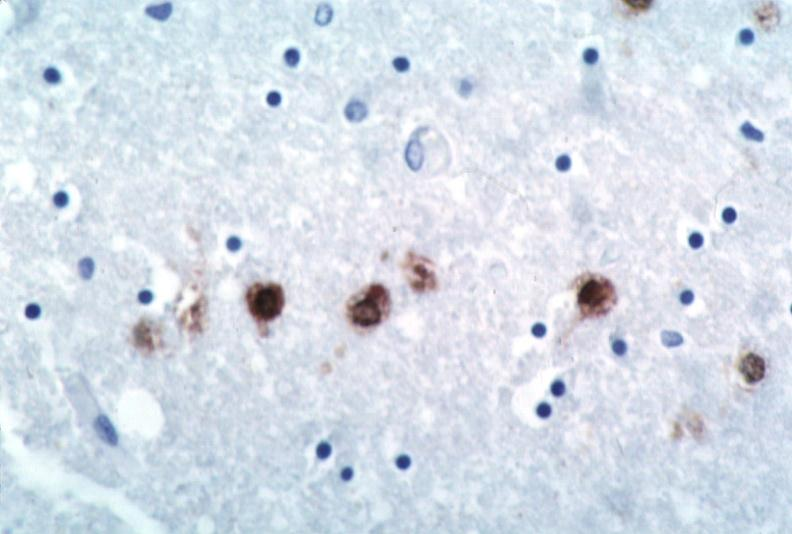what is present?
Answer the question using a single word or phrase. Nervous 